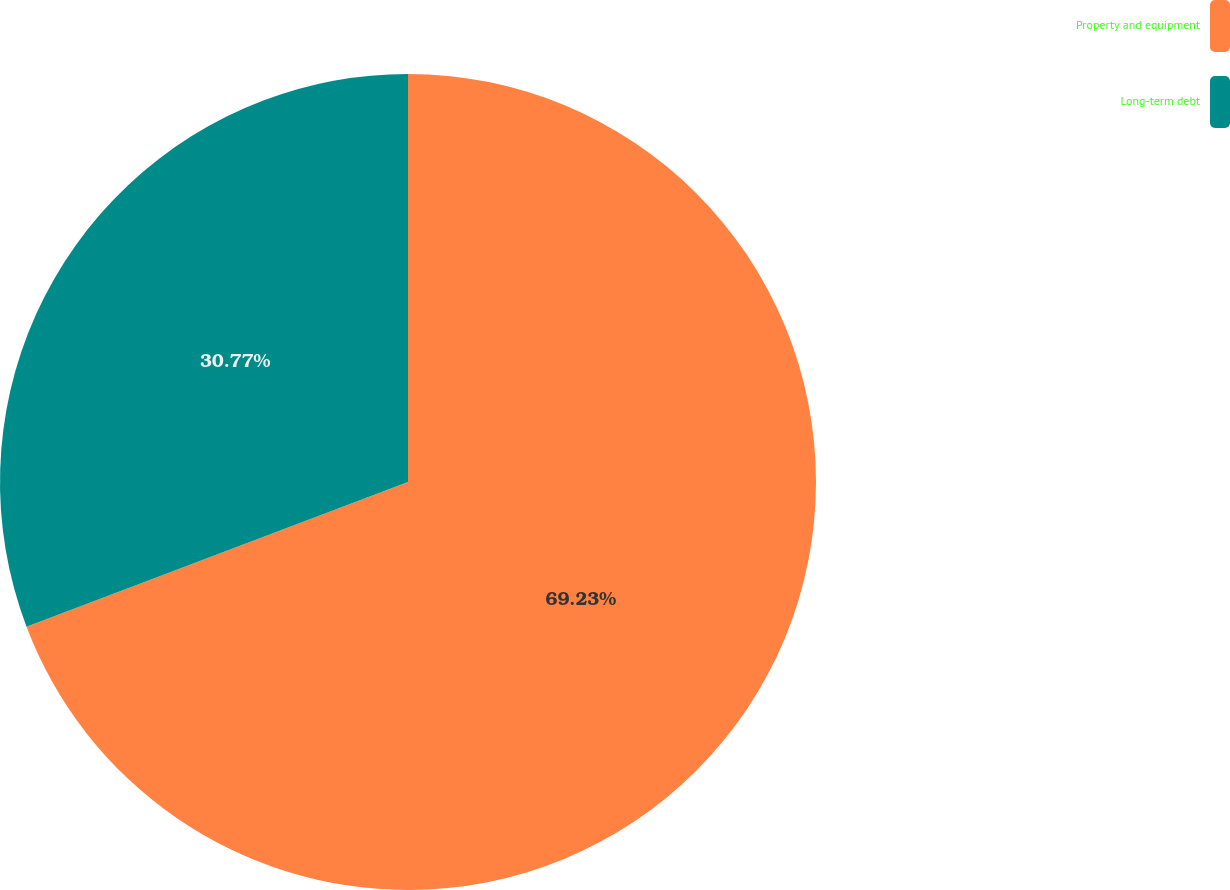Convert chart to OTSL. <chart><loc_0><loc_0><loc_500><loc_500><pie_chart><fcel>Property and equipment<fcel>Long-term debt<nl><fcel>69.23%<fcel>30.77%<nl></chart> 